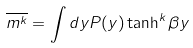Convert formula to latex. <formula><loc_0><loc_0><loc_500><loc_500>\overline { m ^ { k } } = \int d y P ( y ) \tanh ^ { k } \beta y</formula> 